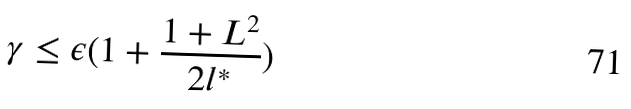<formula> <loc_0><loc_0><loc_500><loc_500>\gamma \leq \epsilon ( 1 + \frac { 1 + L ^ { 2 } } { 2 l ^ { * } } )</formula> 